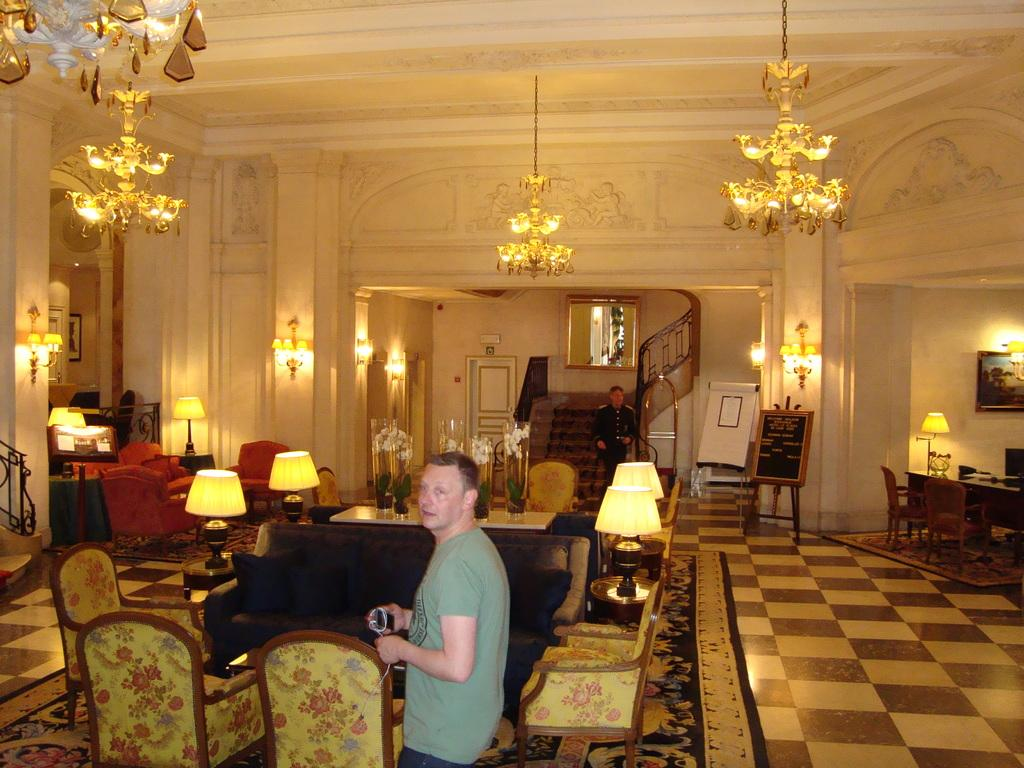What is the man in the image doing? The man is standing in the image and holding a wire in his hand. What type of furniture can be seen in the image? There are chairs and a sofa in the image. Where is the second man located in the image? The second man is standing on stairs in the image. What can be used for illumination in the image? There are lights visible in the image. What type of bead is being used as an apparatus in the image? There is no bead or apparatus present in the image. What type of hospital can be seen in the image? There is no hospital present in the image. 